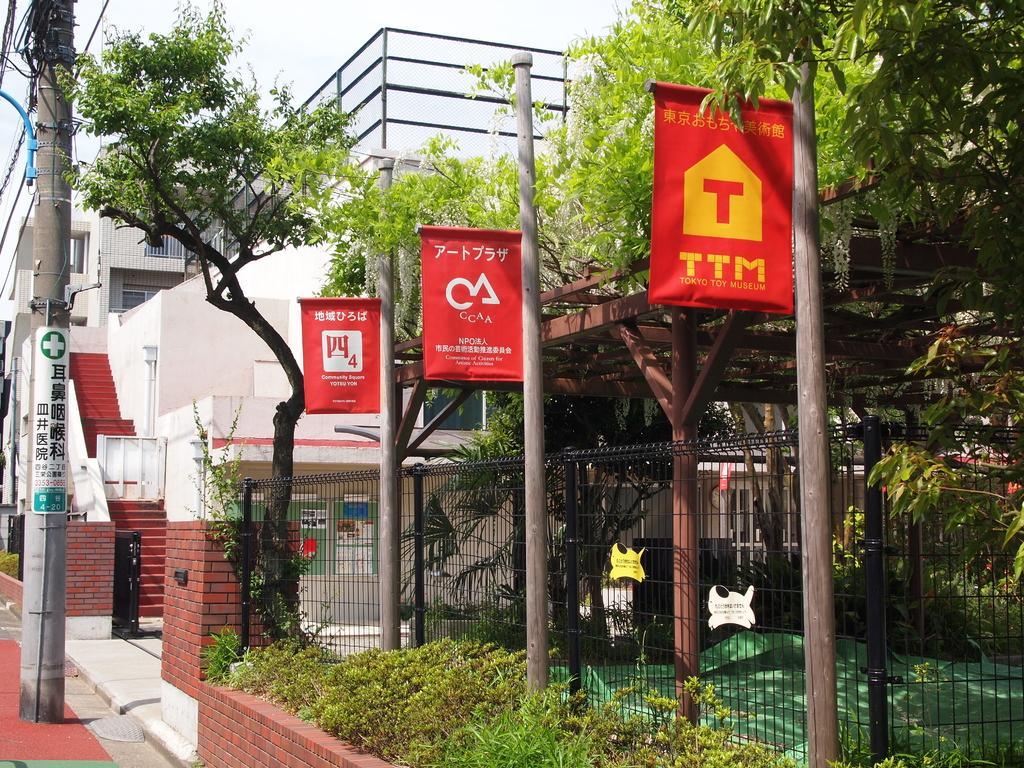Please provide a concise description of this image. In this image in the middle, there are trees, poles, fence, plants, buildings, electric poles, cables, posters, sky. 